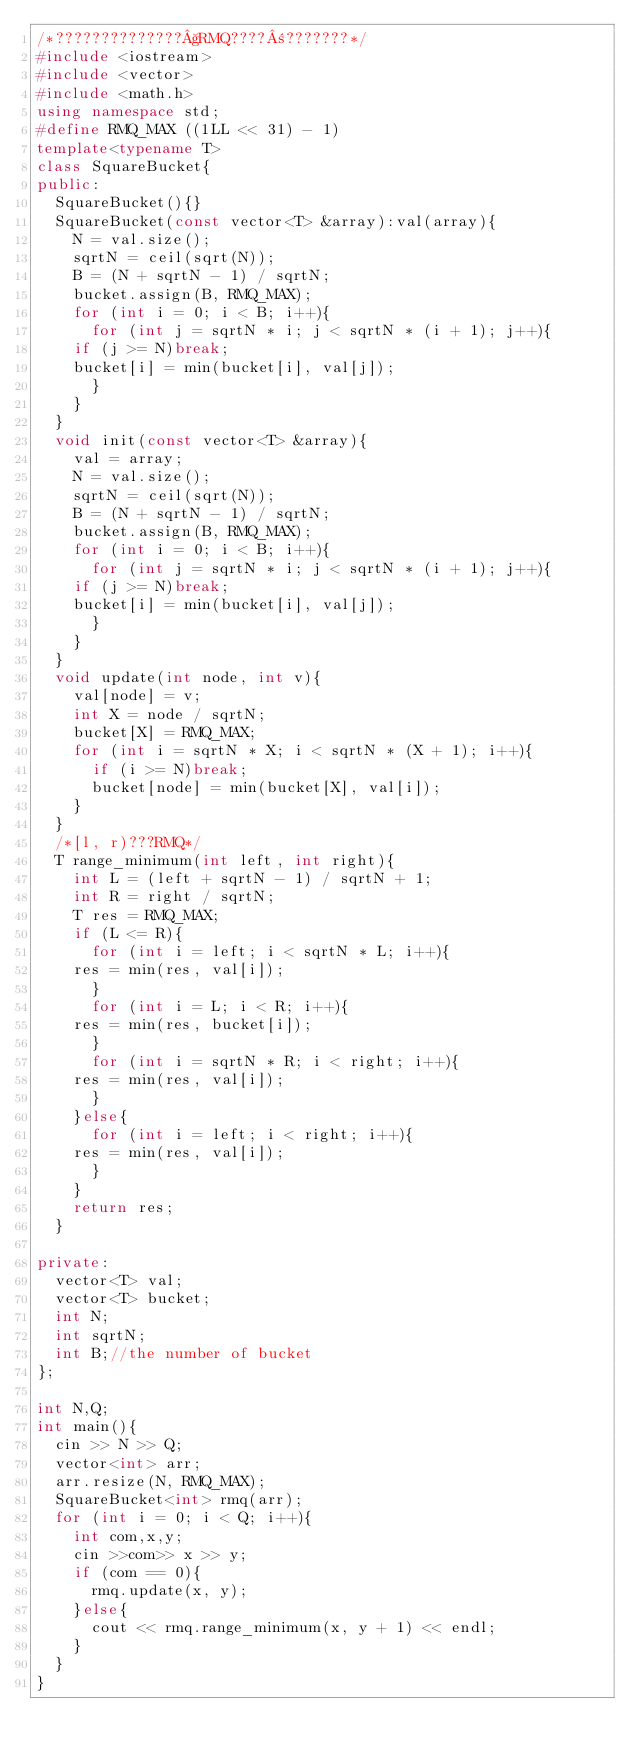<code> <loc_0><loc_0><loc_500><loc_500><_C++_>/*??????????????§RMQ????±???????*/
#include <iostream>
#include <vector>
#include <math.h>
using namespace std;
#define RMQ_MAX ((1LL << 31) - 1)
template<typename T>
class SquareBucket{
public:
  SquareBucket(){}
  SquareBucket(const vector<T> &array):val(array){
    N = val.size();
    sqrtN = ceil(sqrt(N));
    B = (N + sqrtN - 1) / sqrtN;
    bucket.assign(B, RMQ_MAX);
    for (int i = 0; i < B; i++){
      for (int j = sqrtN * i; j < sqrtN * (i + 1); j++){
	if (j >= N)break;
	bucket[i] = min(bucket[i], val[j]);
      }
    }
  }
  void init(const vector<T> &array){
    val = array;
    N = val.size();
    sqrtN = ceil(sqrt(N));
    B = (N + sqrtN - 1) / sqrtN;
    bucket.assign(B, RMQ_MAX);
    for (int i = 0; i < B; i++){
      for (int j = sqrtN * i; j < sqrtN * (i + 1); j++){
	if (j >= N)break;
	bucket[i] = min(bucket[i], val[j]);
      }
    }
  }
  void update(int node, int v){
    val[node] = v;
    int X = node / sqrtN;
    bucket[X] = RMQ_MAX;
    for (int i = sqrtN * X; i < sqrtN * (X + 1); i++){
      if (i >= N)break;
      bucket[node] = min(bucket[X], val[i]);
    }
  }
  /*[l, r)???RMQ*/
  T range_minimum(int left, int right){
    int L = (left + sqrtN - 1) / sqrtN + 1;
    int R = right / sqrtN;
    T res = RMQ_MAX;
    if (L <= R){
      for (int i = left; i < sqrtN * L; i++){
	res = min(res, val[i]);
      }
      for (int i = L; i < R; i++){
	res = min(res, bucket[i]);
      }
      for (int i = sqrtN * R; i < right; i++){
	res = min(res, val[i]);
      }
    }else{
      for (int i = left; i < right; i++){
	res = min(res, val[i]);
      }
    }
    return res;
  }
  
private:
  vector<T> val;
  vector<T> bucket;
  int N;
  int sqrtN;
  int B;//the number of bucket
};

int N,Q;
int main(){
  cin >> N >> Q;
  vector<int> arr;
  arr.resize(N, RMQ_MAX);
  SquareBucket<int> rmq(arr);
  for (int i = 0; i < Q; i++){
    int com,x,y;
    cin >>com>> x >> y;
    if (com == 0){
      rmq.update(x, y);
    }else{
      cout << rmq.range_minimum(x, y + 1) << endl;
    }
  }
}</code> 